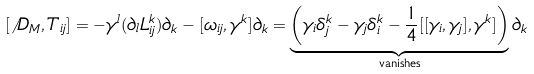Convert formula to latex. <formula><loc_0><loc_0><loc_500><loc_500>[ \not \, { D } _ { M } , { T } _ { i j } ] & = - { \gamma } ^ { l } ( { \partial } _ { l } { L } ^ { k } _ { i j } ) { \partial } _ { k } - [ { \omega } _ { i j } , { \gamma } ^ { k } ] { \partial } _ { k } = \underbrace { \left ( { \gamma } _ { i } { \delta } _ { j } ^ { k } - { \gamma } _ { j } { \delta } _ { i } ^ { k } - \frac { 1 } { 4 } [ [ { \gamma } _ { i } , { \gamma } _ { j } ] , { \gamma } ^ { k } ] \right ) } _ { \text {vanishes} } { \partial } _ { k }</formula> 